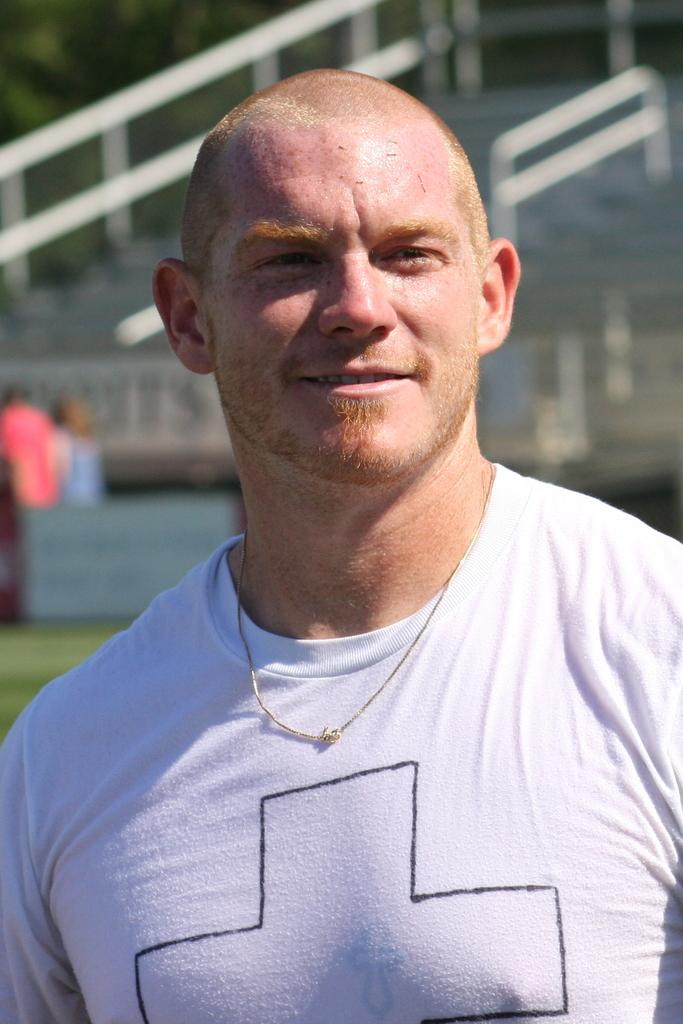What is the main subject in the foreground of the image? There is a person in the foreground of the image. What is the person wearing? The person is wearing a white t-shirt. What can be seen in the background of the image? There is a railing, a staircase, other persons, and trees in the background of the image. What type of stew is being prepared by the fireman on the island in the image? There is no fireman or island present in the image, and therefore no such activity can be observed. 